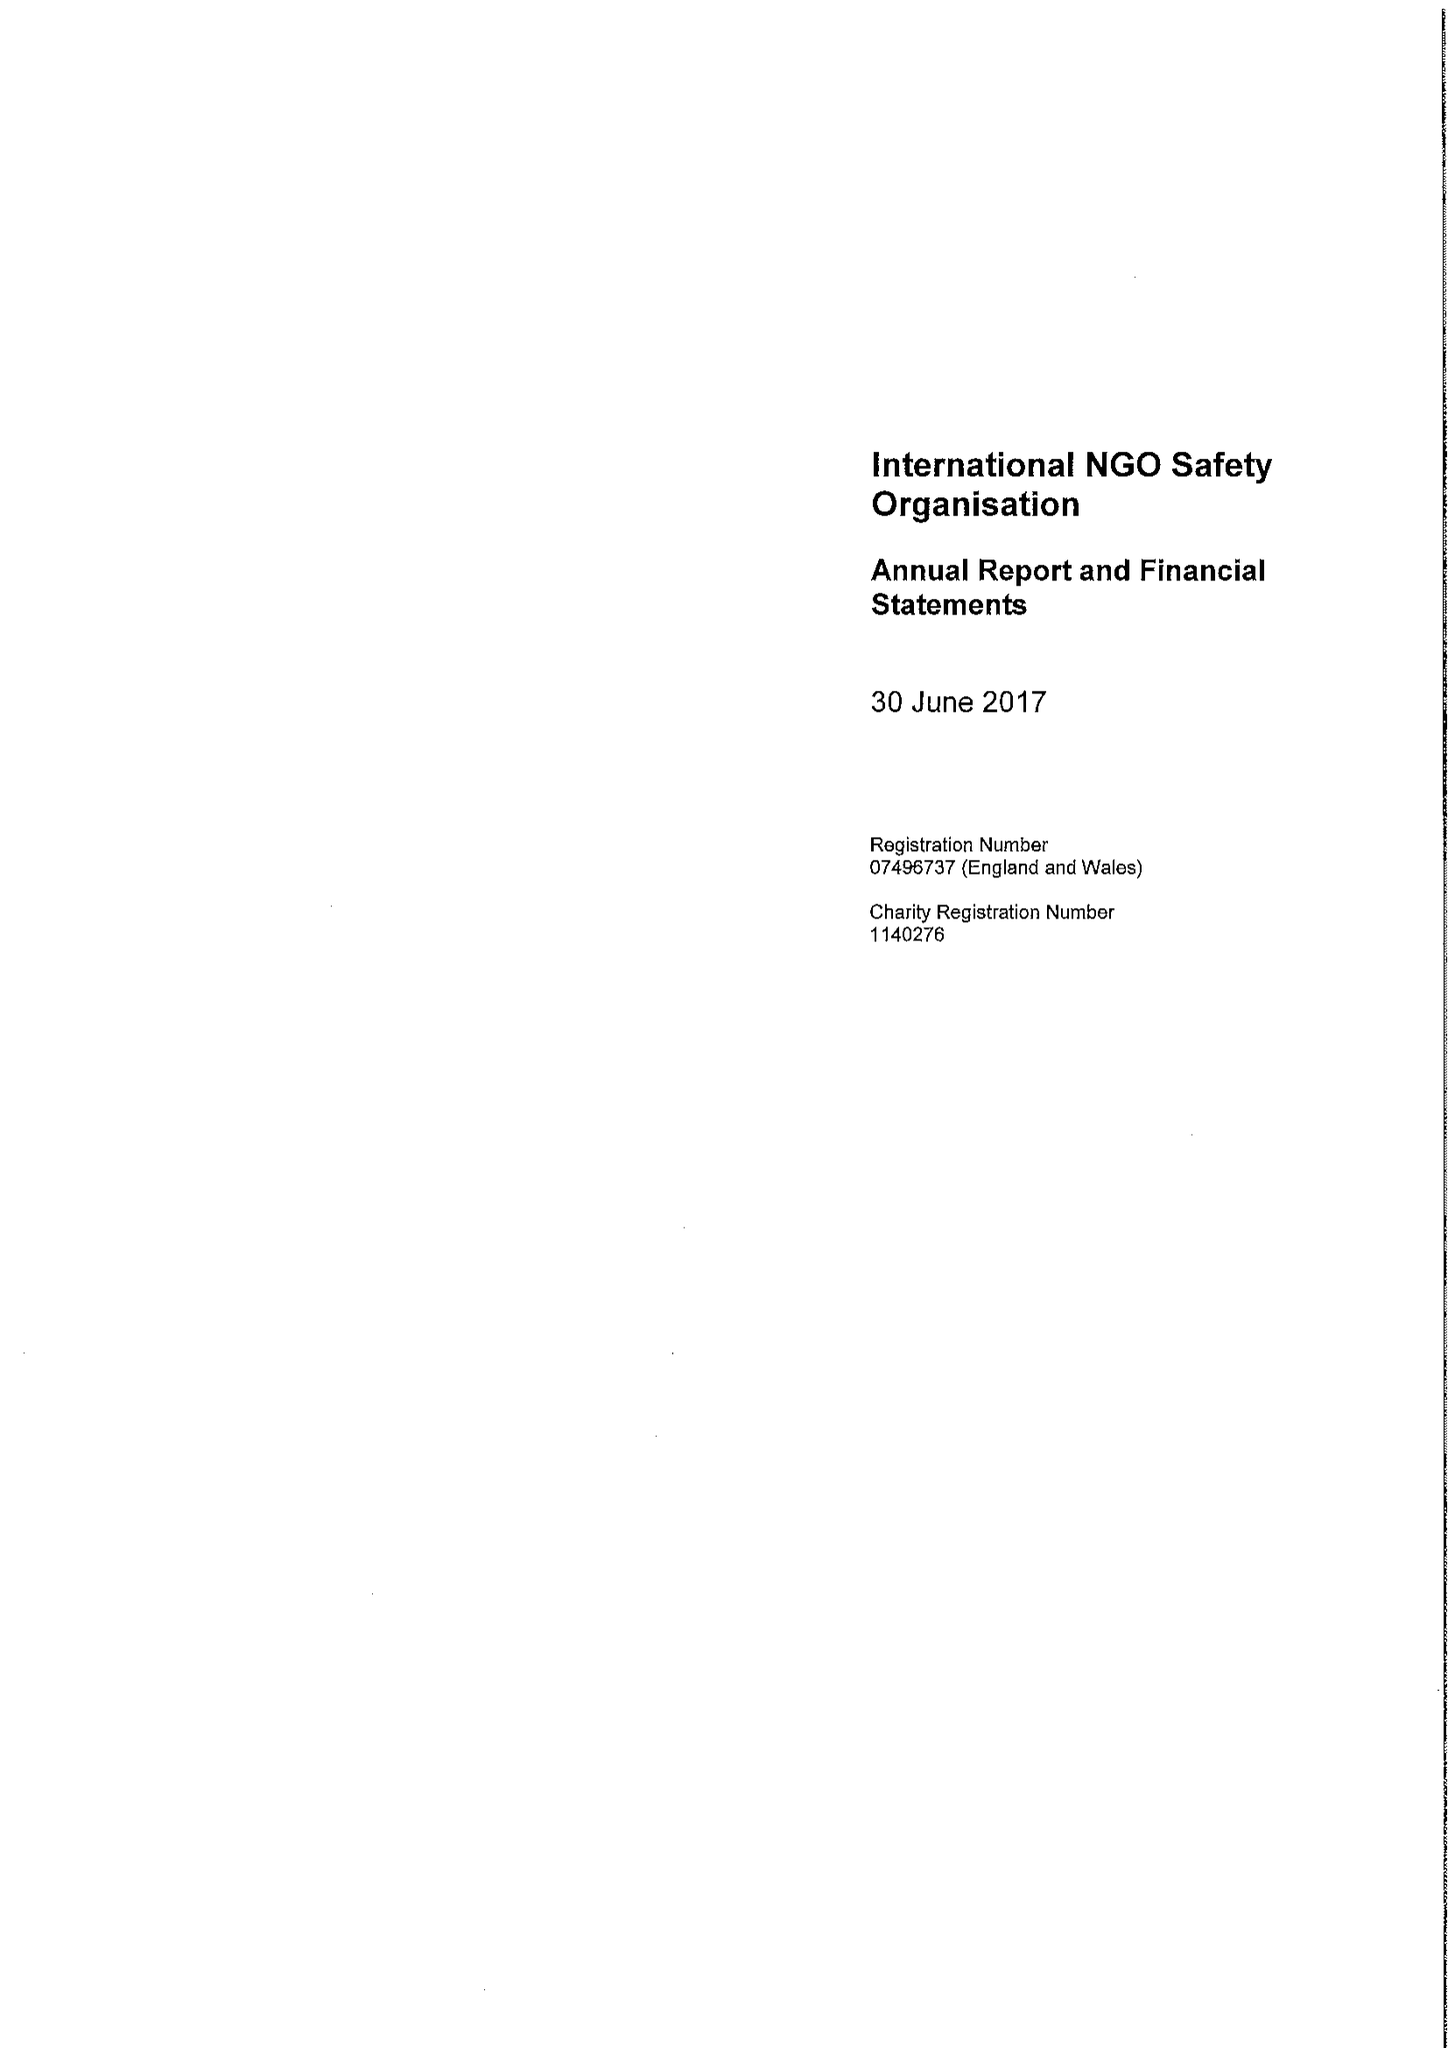What is the value for the charity_number?
Answer the question using a single word or phrase. 1140276 